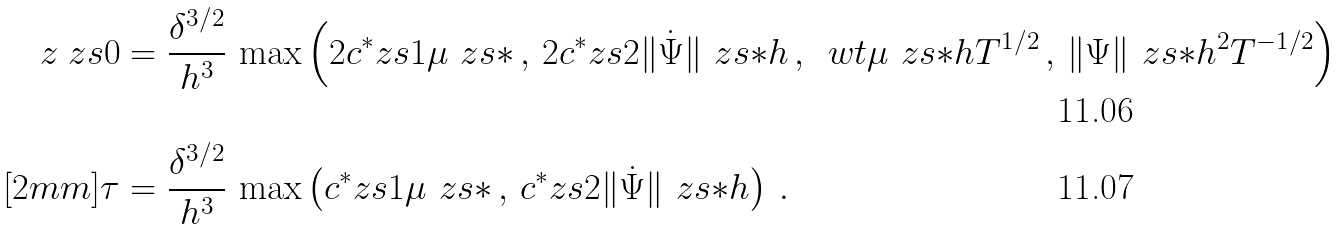<formula> <loc_0><loc_0><loc_500><loc_500>z _ { \ } z s { 0 } & = \frac { \delta ^ { 3 / 2 } } { h ^ { 3 } } \, \max \left ( 2 c ^ { * } _ { \ } z s { 1 } \mu _ { \ } z s { * } \, , \, 2 c ^ { * } _ { \ } z s { 2 } \| \dot { \Psi } \| _ { \ } z s { * } h \, , \, \ w t { \mu } _ { \ } z s { * } h T ^ { 1 / 2 } \, , \, \| \Psi \| _ { \ } z s { * } h ^ { 2 } T ^ { - 1 / 2 } \right ) \\ [ 2 m m ] \tau & = \frac { \delta ^ { 3 / 2 } } { h ^ { 3 } } \, \max \left ( c ^ { * } _ { \ } z s { 1 } \mu _ { \ } z s { * } \, , \, c ^ { * } _ { \ } z s { 2 } \| \dot { \Psi } \| _ { \ } z s { * } h \right ) \, .</formula> 